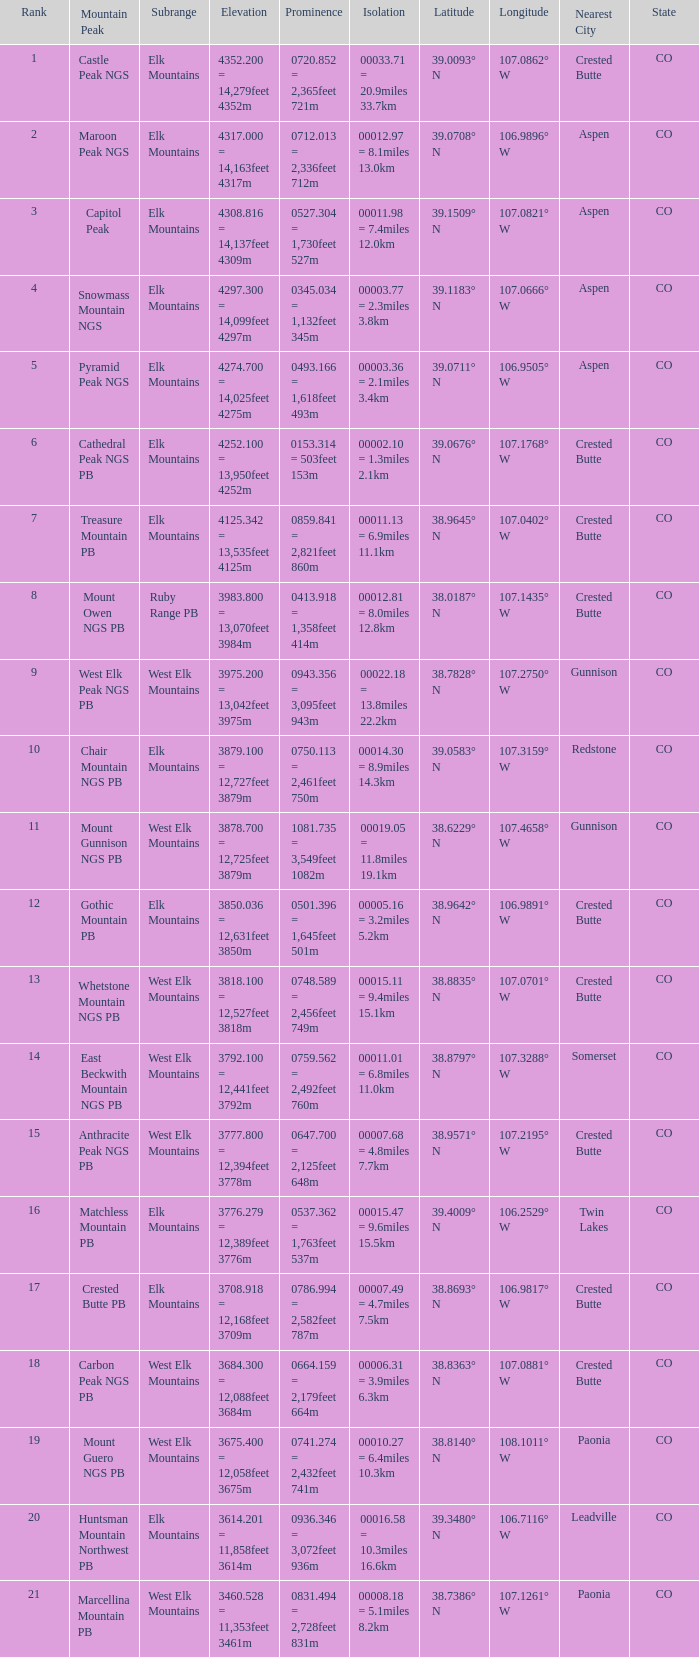Name the Rank of Rank Mountain Peak of crested butte pb? 17.0. Parse the full table. {'header': ['Rank', 'Mountain Peak', 'Subrange', 'Elevation', 'Prominence', 'Isolation', 'Latitude', 'Longitude', 'Nearest City', 'State'], 'rows': [['1', 'Castle Peak NGS', 'Elk Mountains', '4352.200 = 14,279feet 4352m', '0720.852 = 2,365feet 721m', '00033.71 = 20.9miles 33.7km', '39.0093° N', '107.0862° W', 'Crested Butte', 'CO'], ['2', 'Maroon Peak NGS', 'Elk Mountains', '4317.000 = 14,163feet 4317m', '0712.013 = 2,336feet 712m', '00012.97 = 8.1miles 13.0km', '39.0708° N', '106.9896° W', 'Aspen', 'CO'], ['3', 'Capitol Peak', 'Elk Mountains', '4308.816 = 14,137feet 4309m', '0527.304 = 1,730feet 527m', '00011.98 = 7.4miles 12.0km', '39.1509° N', '107.0821° W', 'Aspen', 'CO'], ['4', 'Snowmass Mountain NGS', 'Elk Mountains', '4297.300 = 14,099feet 4297m', '0345.034 = 1,132feet 345m', '00003.77 = 2.3miles 3.8km', '39.1183° N', '107.0666° W', 'Aspen', 'CO'], ['5', 'Pyramid Peak NGS', 'Elk Mountains', '4274.700 = 14,025feet 4275m', '0493.166 = 1,618feet 493m', '00003.36 = 2.1miles 3.4km', '39.0711° N', '106.9505° W', 'Aspen', 'CO'], ['6', 'Cathedral Peak NGS PB', 'Elk Mountains', '4252.100 = 13,950feet 4252m', '0153.314 = 503feet 153m', '00002.10 = 1.3miles 2.1km', '39.0676° N', '107.1768° W', 'Crested Butte', 'CO'], ['7', 'Treasure Mountain PB', 'Elk Mountains', '4125.342 = 13,535feet 4125m', '0859.841 = 2,821feet 860m', '00011.13 = 6.9miles 11.1km', '38.9645° N', '107.0402° W', 'Crested Butte', 'CO'], ['8', 'Mount Owen NGS PB', 'Ruby Range PB', '3983.800 = 13,070feet 3984m', '0413.918 = 1,358feet 414m', '00012.81 = 8.0miles 12.8km', '38.0187° N', '107.1435° W', 'Crested Butte', 'CO'], ['9', 'West Elk Peak NGS PB', 'West Elk Mountains', '3975.200 = 13,042feet 3975m', '0943.356 = 3,095feet 943m', '00022.18 = 13.8miles 22.2km', '38.7828° N', '107.2750° W', 'Gunnison', 'CO'], ['10', 'Chair Mountain NGS PB', 'Elk Mountains', '3879.100 = 12,727feet 3879m', '0750.113 = 2,461feet 750m', '00014.30 = 8.9miles 14.3km', '39.0583° N', '107.3159° W', 'Redstone', 'CO'], ['11', 'Mount Gunnison NGS PB', 'West Elk Mountains', '3878.700 = 12,725feet 3879m', '1081.735 = 3,549feet 1082m', '00019.05 = 11.8miles 19.1km', '38.6229° N', '107.4658° W', 'Gunnison', 'CO'], ['12', 'Gothic Mountain PB', 'Elk Mountains', '3850.036 = 12,631feet 3850m', '0501.396 = 1,645feet 501m', '00005.16 = 3.2miles 5.2km', '38.9642° N', '106.9891° W', 'Crested Butte', 'CO'], ['13', 'Whetstone Mountain NGS PB', 'West Elk Mountains', '3818.100 = 12,527feet 3818m', '0748.589 = 2,456feet 749m', '00015.11 = 9.4miles 15.1km', '38.8835° N', '107.0701° W', 'Crested Butte', 'CO'], ['14', 'East Beckwith Mountain NGS PB', 'West Elk Mountains', '3792.100 = 12,441feet 3792m', '0759.562 = 2,492feet 760m', '00011.01 = 6.8miles 11.0km', '38.8797° N', '107.3288° W', 'Somerset', 'CO'], ['15', 'Anthracite Peak NGS PB', 'West Elk Mountains', '3777.800 = 12,394feet 3778m', '0647.700 = 2,125feet 648m', '00007.68 = 4.8miles 7.7km', '38.9571° N', '107.2195° W', 'Crested Butte', 'CO'], ['16', 'Matchless Mountain PB', 'Elk Mountains', '3776.279 = 12,389feet 3776m', '0537.362 = 1,763feet 537m', '00015.47 = 9.6miles 15.5km', '39.4009° N', '106.2529° W', 'Twin Lakes', 'CO'], ['17', 'Crested Butte PB', 'Elk Mountains', '3708.918 = 12,168feet 3709m', '0786.994 = 2,582feet 787m', '00007.49 = 4.7miles 7.5km', '38.8693° N', '106.9817° W', 'Crested Butte', 'CO'], ['18', 'Carbon Peak NGS PB', 'West Elk Mountains', '3684.300 = 12,088feet 3684m', '0664.159 = 2,179feet 664m', '00006.31 = 3.9miles 6.3km', '38.8363° N', '107.0881° W', 'Crested Butte', 'CO'], ['19', 'Mount Guero NGS PB', 'West Elk Mountains', '3675.400 = 12,058feet 3675m', '0741.274 = 2,432feet 741m', '00010.27 = 6.4miles 10.3km', '38.8140° N', '108.1011° W', 'Paonia', 'CO'], ['20', 'Huntsman Mountain Northwest PB', 'Elk Mountains', '3614.201 = 11,858feet 3614m', '0936.346 = 3,072feet 936m', '00016.58 = 10.3miles 16.6km', '39.3480° N', '106.7116° W', 'Leadville', 'CO'], ['21', 'Marcellina Mountain PB', 'West Elk Mountains', '3460.528 = 11,353feet 3461m', '0831.494 = 2,728feet 831m', '00008.18 = 5.1miles 8.2km', '38.7386° N', '107.1261° W', 'Paonia', 'CO']]} 